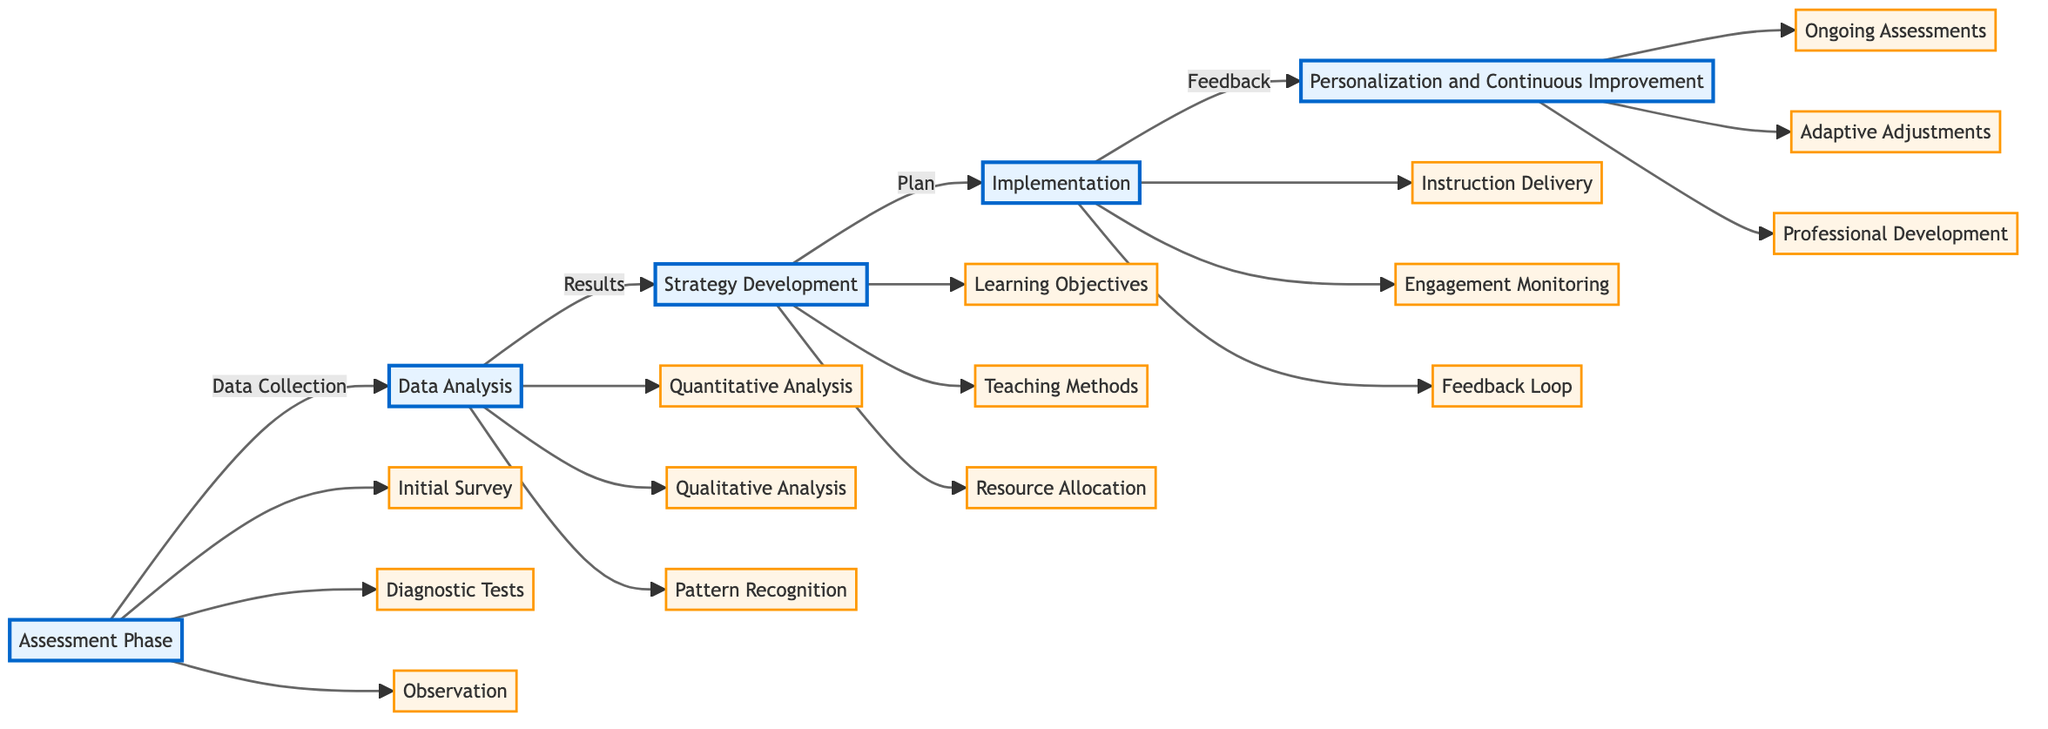What is the first phase in the flowchart? The flowchart starts with the "Assessment Phase," which is connected directly to the "Data Analysis" phase. This is evident as it is the first node in the diagram, leading into the next step.
Answer: Assessment Phase How many components are in the Implementation phase? In the "Implementation" phase, there are three components: "Instruction Delivery," "Engagement Monitoring," and "Feedback Loop." This can be determined by counting the components connected to the "Implementation" node.
Answer: 3 What follows the Data Analysis? The flowchart indicates that "Strategy Development" follows "Data Analysis," creating a direct link between these two phases. This relationship is shown by the arrow connecting Data Analysis to Strategy Development.
Answer: Strategy Development Which component is part of the Strategy Development phase? "Learning Objectives" is one of the components of the "Strategy Development" phase, as it is directly connected to it. The flowchart clearly shows this component branching from the Strategy Development node.
Answer: Learning Objectives What is the last phase presented in the flowchart? The final phase in the flowchart is "Personalization and Continuous Improvement," which follows the "Implementation" phase. This can be confirmed by looking at the last node in the flow from the Implementation phase.
Answer: Personalization and Continuous Improvement How many phases are displayed in the flowchart? There are five distinct phases displayed in the flowchart: "Assessment Phase," "Data Analysis," "Strategy Development," "Implementation," and "Personalization and Continuous Improvement." This can be confirmed by counting the main nodes connected sequentially.
Answer: 5 What is the purpose of the Data Analysis phase? The purpose of the "Data Analysis" phase is to analyze the collected data to identify patterns and preferences, as described in the phase's main description within the flowchart.
Answer: Analyze data Which component can be used for ongoing assessments in the last phase? In the "Personalization and Continuous Improvement" phase, one of the components is "Ongoing Assessments," which is aimed at frequent evaluations to gauge progress. This component is clearly identified within that phase.
Answer: Ongoing Assessments What type of analysis is involved in the Data Analysis phase? The "Data Analysis" phase involves both "Quantitative Analysis" and "Qualitative Analysis" as its components, which are essential for interpreting the collected data. This can be verified through the connections branching from the Data Analysis phase.
Answer: Quantitative Analysis and Qualitative Analysis 